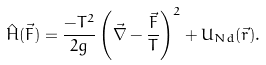Convert formula to latex. <formula><loc_0><loc_0><loc_500><loc_500>\hat { H } ( \vec { F } ) = \frac { - T ^ { 2 } } { 2 g } \left ( \vec { \nabla } - \frac { \vec { F } } { T } \right ) ^ { 2 } + U _ { N d } ( \vec { r } ) .</formula> 